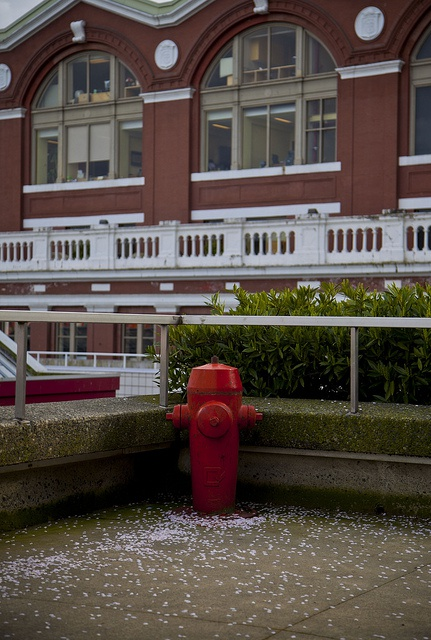Describe the objects in this image and their specific colors. I can see a fire hydrant in darkgray, maroon, black, and brown tones in this image. 